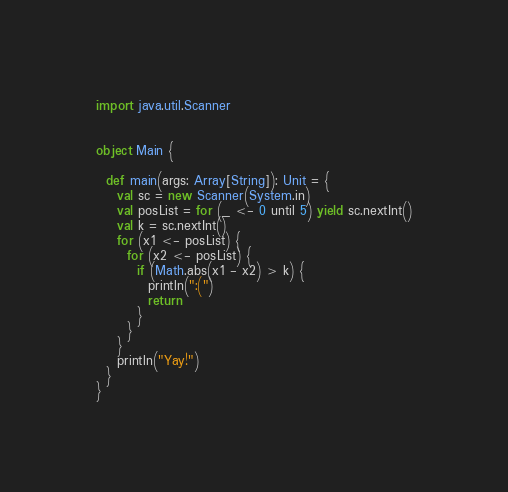<code> <loc_0><loc_0><loc_500><loc_500><_Scala_>import java.util.Scanner


object Main {

  def main(args: Array[String]): Unit = {
    val sc = new Scanner(System.in)
    val posList = for (_ <- 0 until 5) yield sc.nextInt()
    val k = sc.nextInt()
    for (x1 <- posList) {
      for (x2 <- posList) {
        if (Math.abs(x1 - x2) > k) {
          println(":(")
          return
        }
      }
    }
    println("Yay!")
  }
}</code> 